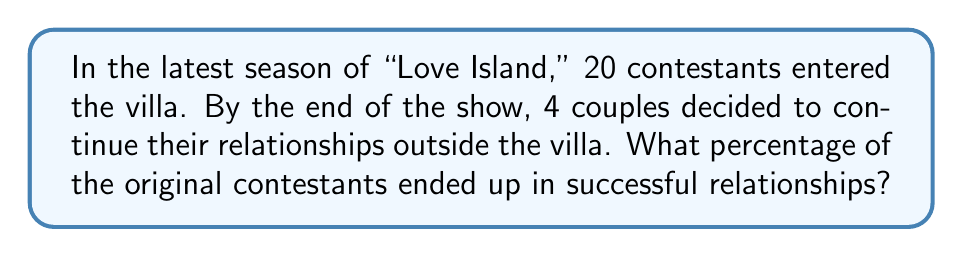What is the answer to this math problem? Let's approach this step-by-step:

1. First, we need to determine how many contestants are in successful relationships:
   - Each couple consists of 2 people
   - There are 4 successful couples
   - So, the number of people in successful relationships is: $4 \times 2 = 8$

2. Now, we can calculate the percentage:
   - Total number of contestants: 20
   - Number of contestants in successful relationships: 8
   - To calculate the percentage, we use the formula:
     $$ \text{Percentage} = \frac{\text{Part}}{\text{Whole}} \times 100\% $$

3. Plugging in our numbers:
   $$ \text{Percentage} = \frac{8}{20} \times 100\% $$

4. Simplify the fraction:
   $$ \text{Percentage} = \frac{2}{5} \times 100\% $$

5. Perform the multiplication:
   $$ \text{Percentage} = 0.4 \times 100\% = 40\% $$

Therefore, 40% of the original contestants ended up in successful relationships.
Answer: 40% 